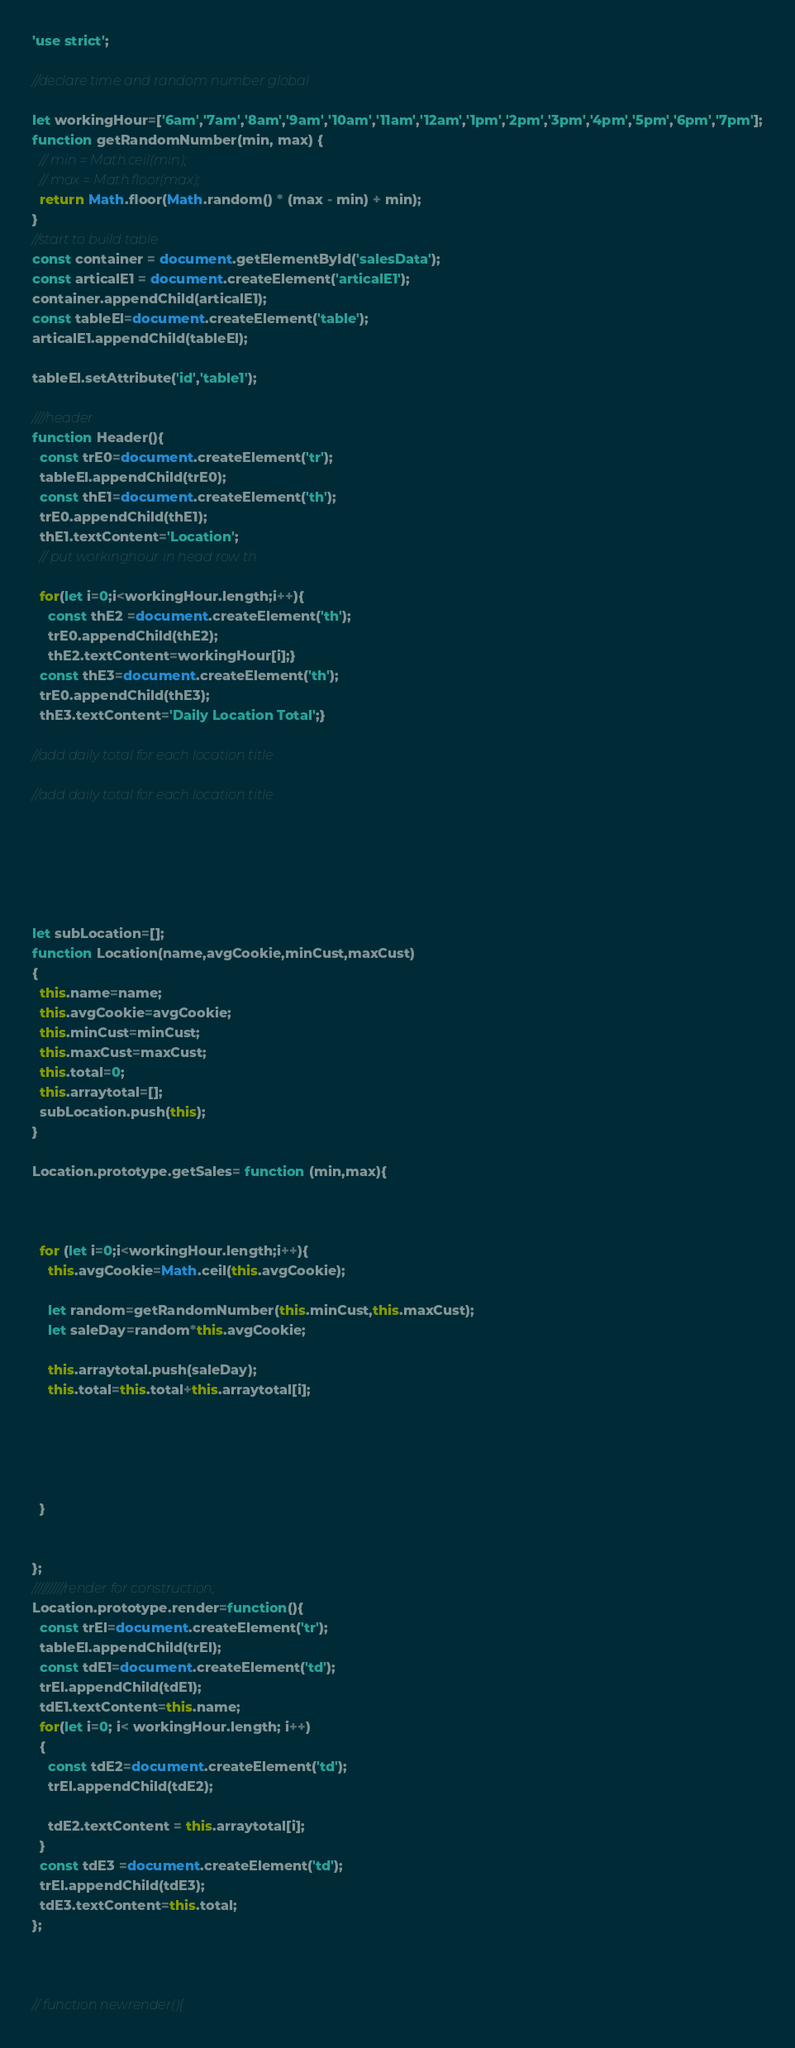Convert code to text. <code><loc_0><loc_0><loc_500><loc_500><_JavaScript_>'use strict';

//declare time and random number global

let workingHour=['6am','7am','8am','9am','10am','11am','12am','1pm','2pm','3pm','4pm','5pm','6pm','7pm'];
function getRandomNumber(min, max) {
  // min = Math.ceil(min);
  // max = Math.floor(max);
  return Math.floor(Math.random() * (max - min) + min);
}
//start to build table
const container = document.getElementById('salesData');
const articalE1 = document.createElement('articalE1');
container.appendChild(articalE1);
const tableEl=document.createElement('table');
articalE1.appendChild(tableEl);

tableEl.setAttribute('id','table1');

////header
function Header(){
  const trE0=document.createElement('tr');
  tableEl.appendChild(trE0);
  const thE1=document.createElement('th');
  trE0.appendChild(thE1);
  thE1.textContent='Location';
  // put workinghour in head row th

  for(let i=0;i<workingHour.length;i++){
    const thE2 =document.createElement('th');
    trE0.appendChild(thE2);
    thE2.textContent=workingHour[i];}
  const thE3=document.createElement('th');
  trE0.appendChild(thE3);
  thE3.textContent='Daily Location Total';}

//add daily total for each location title

//add daily total for each location title






let subLocation=[];
function Location(name,avgCookie,minCust,maxCust)
{
  this.name=name;
  this.avgCookie=avgCookie;
  this.minCust=minCust;
  this.maxCust=maxCust;
  this.total=0;
  this.arraytotal=[];
  subLocation.push(this);
}

Location.prototype.getSales= function (min,max){



  for (let i=0;i<workingHour.length;i++){
    this.avgCookie=Math.ceil(this.avgCookie);

    let random=getRandomNumber(this.minCust,this.maxCust);
    let saleDay=random*this.avgCookie;

    this.arraytotal.push(saleDay);
    this.total=this.total+this.arraytotal[i];





  }


};
//////////render for construction;
Location.prototype.render=function(){
  const trEl=document.createElement('tr');
  tableEl.appendChild(trEl);
  const tdE1=document.createElement('td');
  trEl.appendChild(tdE1);
  tdE1.textContent=this.name;
  for(let i=0; i< workingHour.length; i++)
  {
    const tdE2=document.createElement('td');
    trEl.appendChild(tdE2);

    tdE2.textContent = this.arraytotal[i];
  }
  const tdE3 =document.createElement('td');
  trEl.appendChild(tdE3);
  tdE3.textContent=this.total;
};



// function newrender(){</code> 